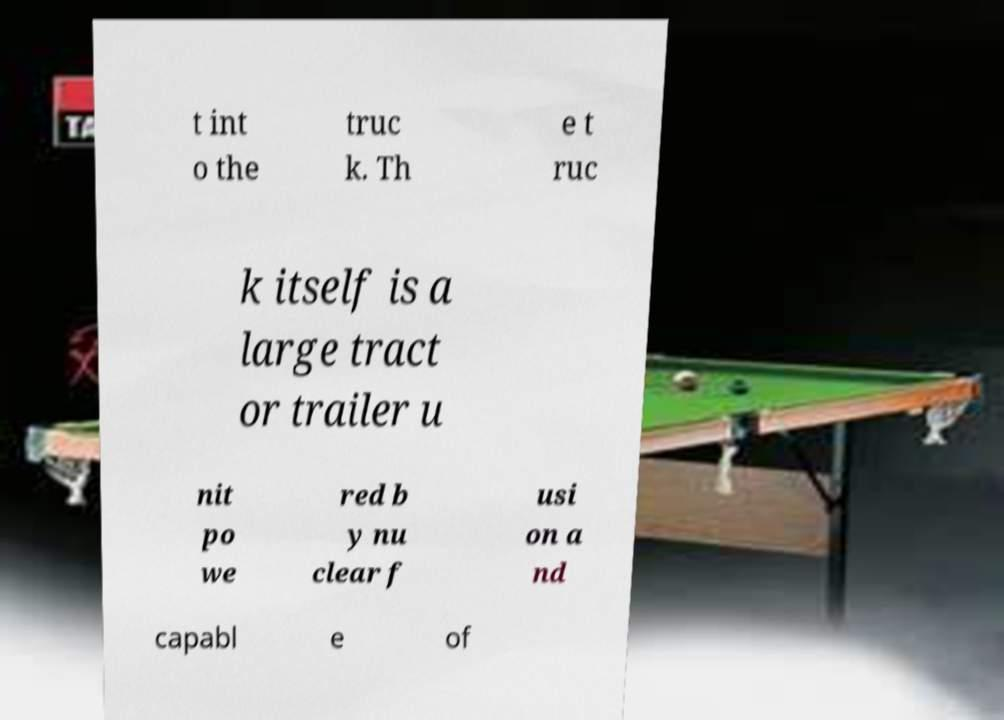Please identify and transcribe the text found in this image. t int o the truc k. Th e t ruc k itself is a large tract or trailer u nit po we red b y nu clear f usi on a nd capabl e of 